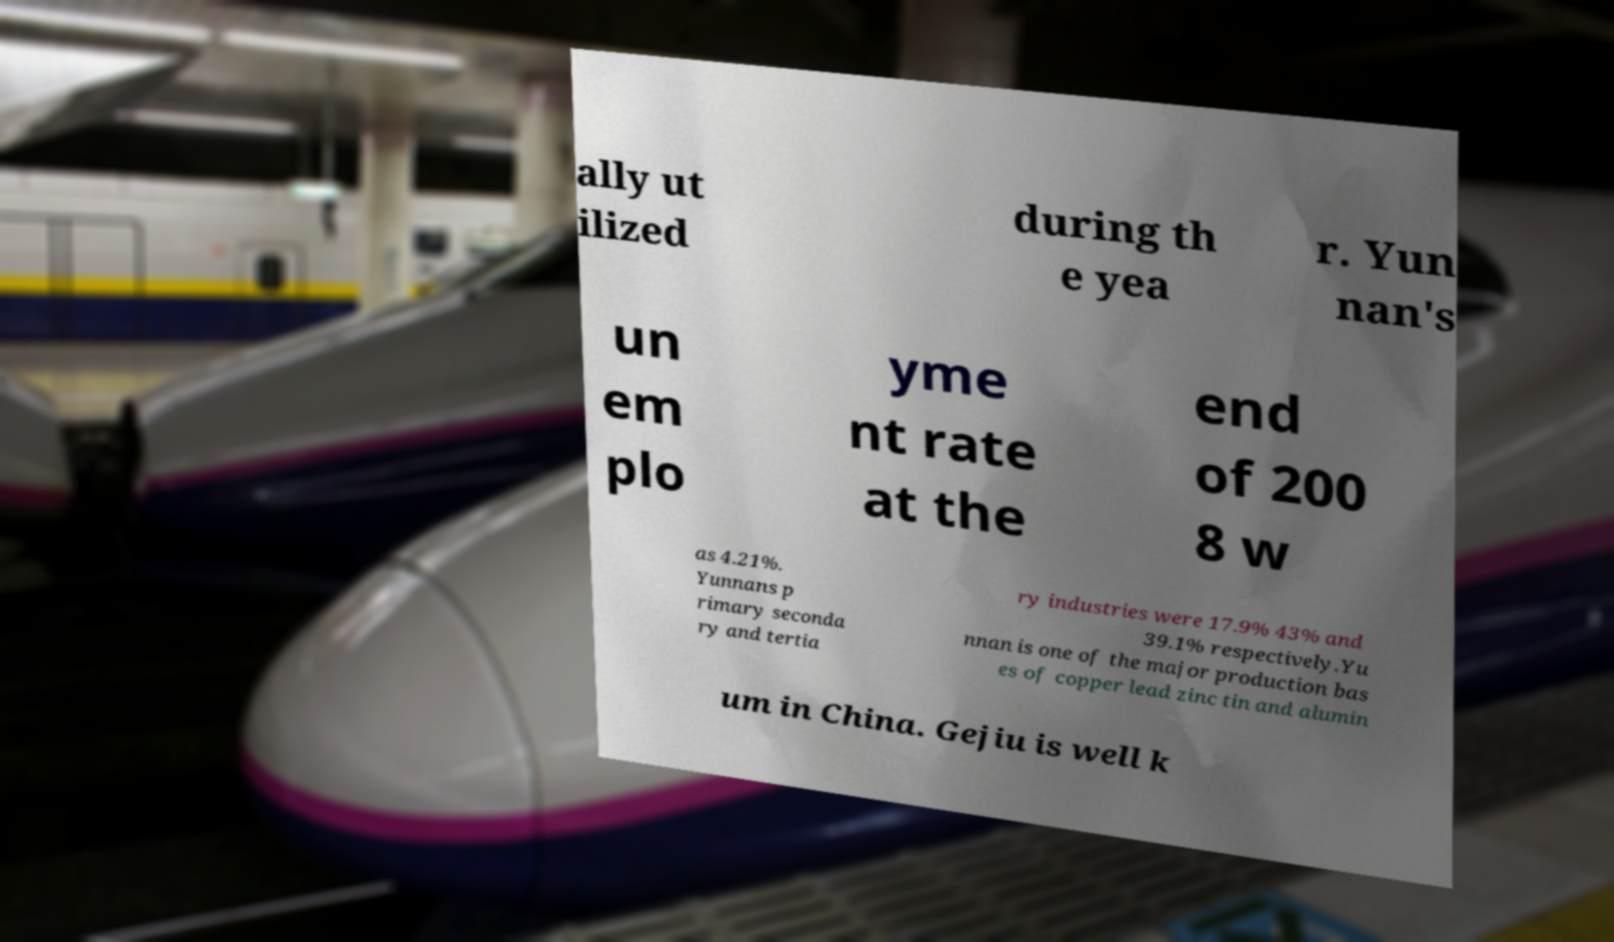What messages or text are displayed in this image? I need them in a readable, typed format. ally ut ilized during th e yea r. Yun nan's un em plo yme nt rate at the end of 200 8 w as 4.21%. Yunnans p rimary seconda ry and tertia ry industries were 17.9% 43% and 39.1% respectively.Yu nnan is one of the major production bas es of copper lead zinc tin and alumin um in China. Gejiu is well k 